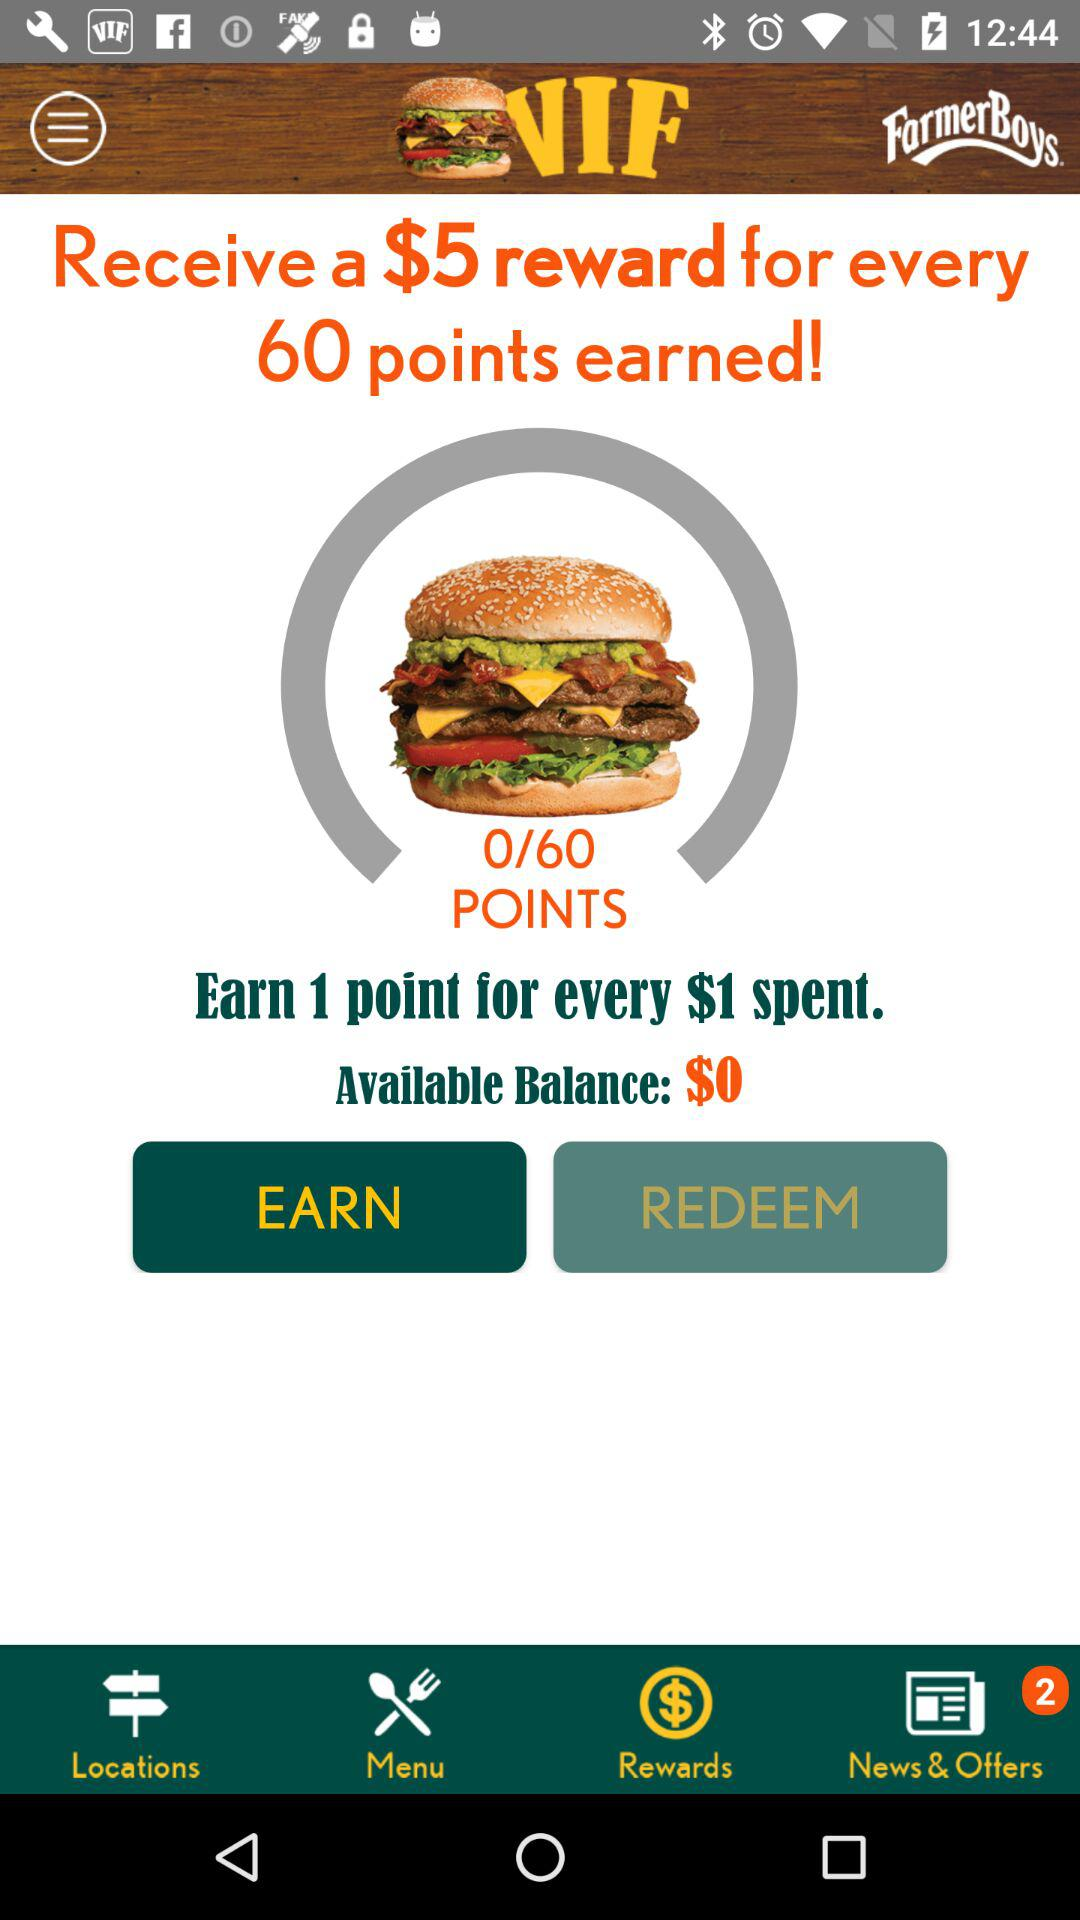How much money do I need to spend to earn 1 point?
Answer the question using a single word or phrase. $1 